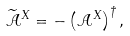Convert formula to latex. <formula><loc_0><loc_0><loc_500><loc_500>\widetilde { \mathcal { A } } ^ { X } = - \left ( { \mathcal { A } } ^ { X } \right ) ^ { \dagger } ,</formula> 